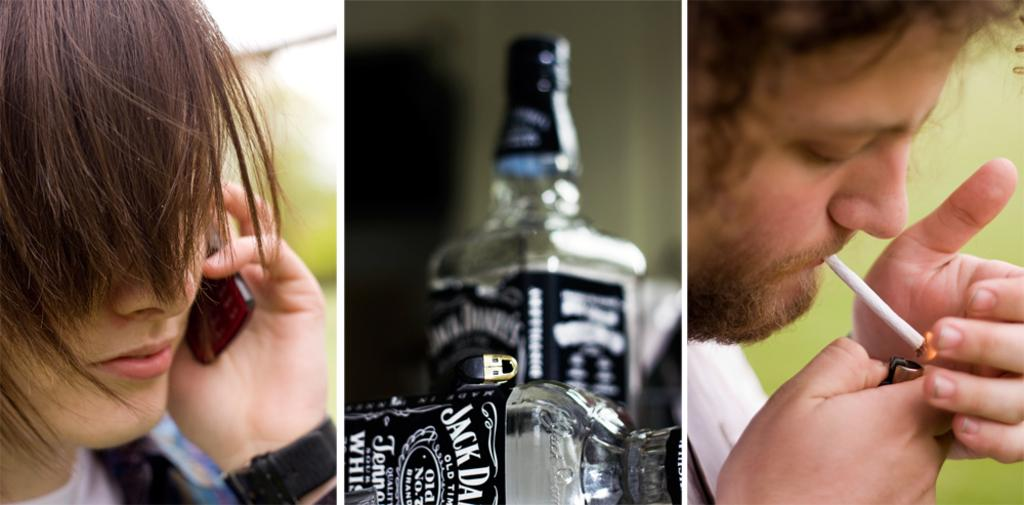<image>
Give a short and clear explanation of the subsequent image. Two bottles of Jack Daniel's Whiskey with black labels and white writing. 